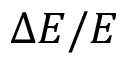<formula> <loc_0><loc_0><loc_500><loc_500>\Delta E / E</formula> 